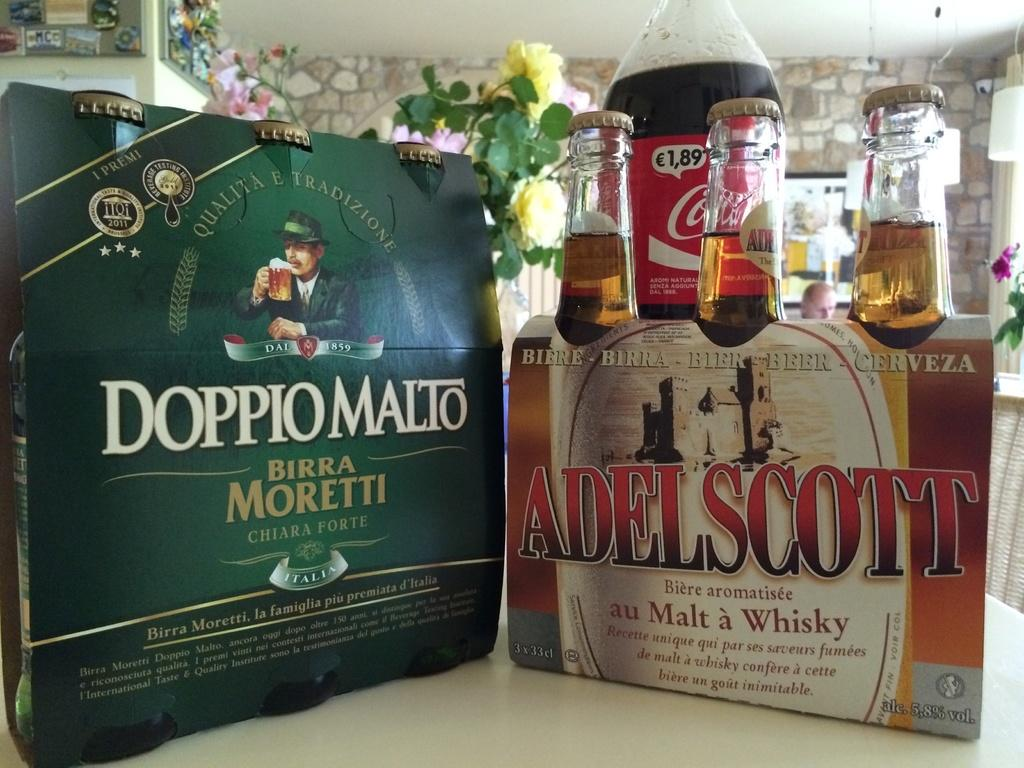Provide a one-sentence caption for the provided image. Two packs of bottled liquor which one is Adelscott and the other Doppiomalto with a two liter of Coke Cola in the background. 